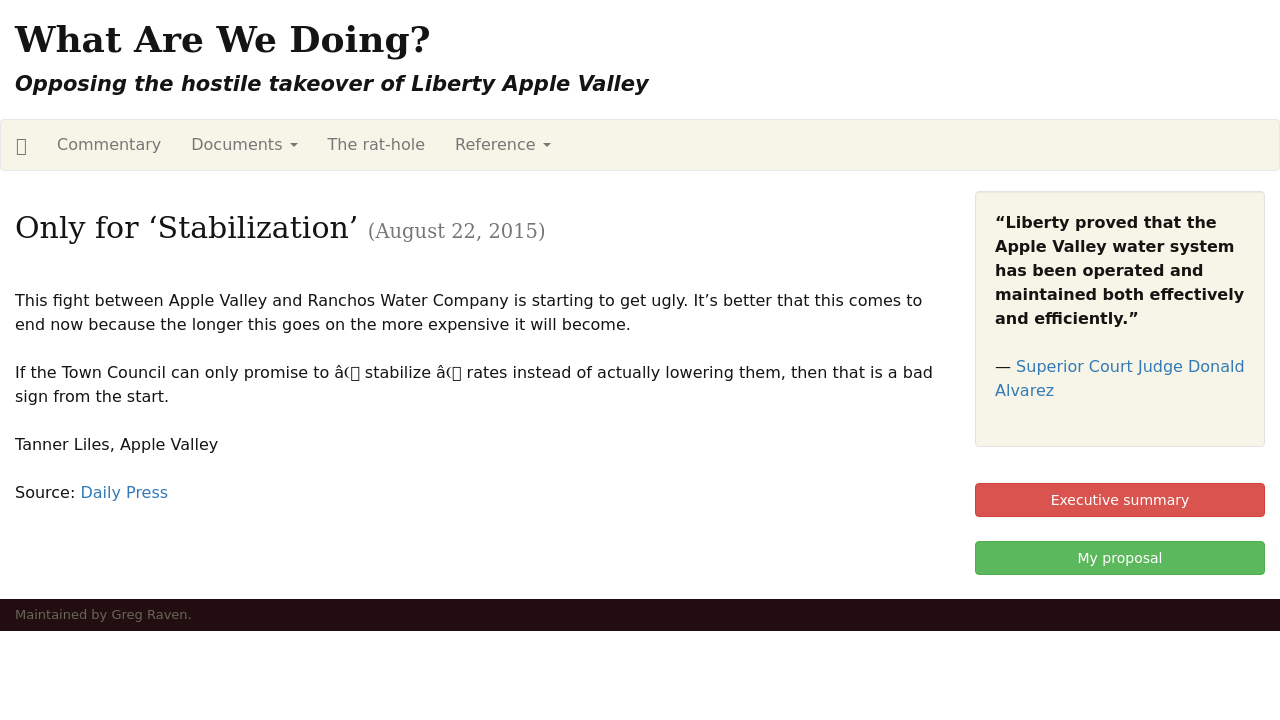What details can you provide about the communications and design of the website shown in the image? The website features a clean and professional design, using a minimalist set of colors predominantly in white and black, which helps focus the visitor's attention on the text content. The navigation bar includes links to various sections such as Commentary, Documents, The rat-hole, and Reference, making it easy for visitors to find specific information. The text layout is straightforward, enhancing readability. There's also a focus on community involvement, as seen in the 'Executive summary' and 'My proposal' buttons indicating active engagement initiatives. 